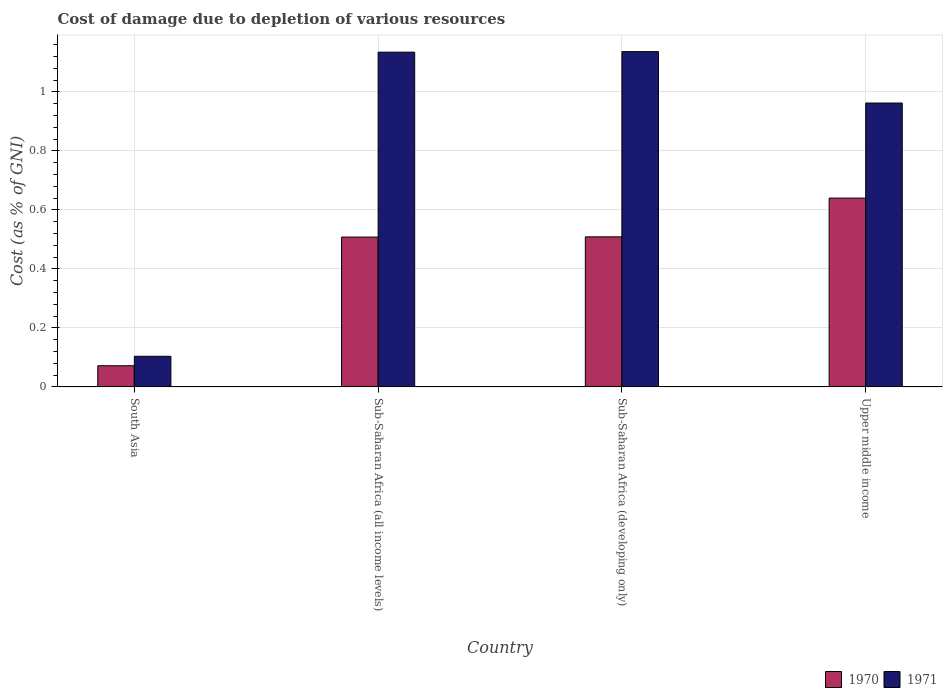How many different coloured bars are there?
Offer a very short reply. 2. How many groups of bars are there?
Make the answer very short. 4. Are the number of bars on each tick of the X-axis equal?
Your answer should be very brief. Yes. What is the label of the 1st group of bars from the left?
Offer a very short reply. South Asia. In how many cases, is the number of bars for a given country not equal to the number of legend labels?
Offer a terse response. 0. What is the cost of damage caused due to the depletion of various resources in 1970 in Sub-Saharan Africa (developing only)?
Your answer should be compact. 0.51. Across all countries, what is the maximum cost of damage caused due to the depletion of various resources in 1970?
Give a very brief answer. 0.64. Across all countries, what is the minimum cost of damage caused due to the depletion of various resources in 1971?
Offer a very short reply. 0.1. In which country was the cost of damage caused due to the depletion of various resources in 1971 maximum?
Provide a succinct answer. Sub-Saharan Africa (developing only). What is the total cost of damage caused due to the depletion of various resources in 1970 in the graph?
Your answer should be very brief. 1.73. What is the difference between the cost of damage caused due to the depletion of various resources in 1971 in South Asia and that in Upper middle income?
Give a very brief answer. -0.86. What is the difference between the cost of damage caused due to the depletion of various resources in 1970 in South Asia and the cost of damage caused due to the depletion of various resources in 1971 in Sub-Saharan Africa (developing only)?
Your answer should be very brief. -1.07. What is the average cost of damage caused due to the depletion of various resources in 1970 per country?
Offer a terse response. 0.43. What is the difference between the cost of damage caused due to the depletion of various resources of/in 1970 and cost of damage caused due to the depletion of various resources of/in 1971 in Sub-Saharan Africa (all income levels)?
Your response must be concise. -0.63. In how many countries, is the cost of damage caused due to the depletion of various resources in 1971 greater than 1.04 %?
Provide a short and direct response. 2. What is the ratio of the cost of damage caused due to the depletion of various resources in 1971 in Sub-Saharan Africa (all income levels) to that in Sub-Saharan Africa (developing only)?
Make the answer very short. 1. What is the difference between the highest and the second highest cost of damage caused due to the depletion of various resources in 1970?
Give a very brief answer. 0.13. What is the difference between the highest and the lowest cost of damage caused due to the depletion of various resources in 1971?
Make the answer very short. 1.03. Are all the bars in the graph horizontal?
Make the answer very short. No. How many countries are there in the graph?
Provide a succinct answer. 4. What is the difference between two consecutive major ticks on the Y-axis?
Provide a short and direct response. 0.2. Are the values on the major ticks of Y-axis written in scientific E-notation?
Make the answer very short. No. Does the graph contain any zero values?
Provide a short and direct response. No. Where does the legend appear in the graph?
Offer a very short reply. Bottom right. What is the title of the graph?
Give a very brief answer. Cost of damage due to depletion of various resources. Does "2009" appear as one of the legend labels in the graph?
Offer a terse response. No. What is the label or title of the Y-axis?
Offer a very short reply. Cost (as % of GNI). What is the Cost (as % of GNI) of 1970 in South Asia?
Offer a terse response. 0.07. What is the Cost (as % of GNI) in 1971 in South Asia?
Make the answer very short. 0.1. What is the Cost (as % of GNI) of 1970 in Sub-Saharan Africa (all income levels)?
Ensure brevity in your answer.  0.51. What is the Cost (as % of GNI) in 1971 in Sub-Saharan Africa (all income levels)?
Your response must be concise. 1.13. What is the Cost (as % of GNI) of 1970 in Sub-Saharan Africa (developing only)?
Give a very brief answer. 0.51. What is the Cost (as % of GNI) in 1971 in Sub-Saharan Africa (developing only)?
Make the answer very short. 1.14. What is the Cost (as % of GNI) of 1970 in Upper middle income?
Your answer should be compact. 0.64. What is the Cost (as % of GNI) of 1971 in Upper middle income?
Keep it short and to the point. 0.96. Across all countries, what is the maximum Cost (as % of GNI) in 1970?
Provide a short and direct response. 0.64. Across all countries, what is the maximum Cost (as % of GNI) of 1971?
Offer a very short reply. 1.14. Across all countries, what is the minimum Cost (as % of GNI) of 1970?
Offer a very short reply. 0.07. Across all countries, what is the minimum Cost (as % of GNI) of 1971?
Offer a terse response. 0.1. What is the total Cost (as % of GNI) in 1970 in the graph?
Your response must be concise. 1.73. What is the total Cost (as % of GNI) in 1971 in the graph?
Give a very brief answer. 3.34. What is the difference between the Cost (as % of GNI) of 1970 in South Asia and that in Sub-Saharan Africa (all income levels)?
Provide a succinct answer. -0.44. What is the difference between the Cost (as % of GNI) in 1971 in South Asia and that in Sub-Saharan Africa (all income levels)?
Ensure brevity in your answer.  -1.03. What is the difference between the Cost (as % of GNI) in 1970 in South Asia and that in Sub-Saharan Africa (developing only)?
Give a very brief answer. -0.44. What is the difference between the Cost (as % of GNI) of 1971 in South Asia and that in Sub-Saharan Africa (developing only)?
Make the answer very short. -1.03. What is the difference between the Cost (as % of GNI) in 1970 in South Asia and that in Upper middle income?
Ensure brevity in your answer.  -0.57. What is the difference between the Cost (as % of GNI) of 1971 in South Asia and that in Upper middle income?
Provide a succinct answer. -0.86. What is the difference between the Cost (as % of GNI) in 1970 in Sub-Saharan Africa (all income levels) and that in Sub-Saharan Africa (developing only)?
Make the answer very short. -0. What is the difference between the Cost (as % of GNI) of 1971 in Sub-Saharan Africa (all income levels) and that in Sub-Saharan Africa (developing only)?
Offer a terse response. -0. What is the difference between the Cost (as % of GNI) of 1970 in Sub-Saharan Africa (all income levels) and that in Upper middle income?
Make the answer very short. -0.13. What is the difference between the Cost (as % of GNI) of 1971 in Sub-Saharan Africa (all income levels) and that in Upper middle income?
Keep it short and to the point. 0.17. What is the difference between the Cost (as % of GNI) of 1970 in Sub-Saharan Africa (developing only) and that in Upper middle income?
Provide a succinct answer. -0.13. What is the difference between the Cost (as % of GNI) in 1971 in Sub-Saharan Africa (developing only) and that in Upper middle income?
Provide a succinct answer. 0.17. What is the difference between the Cost (as % of GNI) of 1970 in South Asia and the Cost (as % of GNI) of 1971 in Sub-Saharan Africa (all income levels)?
Make the answer very short. -1.06. What is the difference between the Cost (as % of GNI) of 1970 in South Asia and the Cost (as % of GNI) of 1971 in Sub-Saharan Africa (developing only)?
Offer a very short reply. -1.07. What is the difference between the Cost (as % of GNI) in 1970 in South Asia and the Cost (as % of GNI) in 1971 in Upper middle income?
Provide a succinct answer. -0.89. What is the difference between the Cost (as % of GNI) of 1970 in Sub-Saharan Africa (all income levels) and the Cost (as % of GNI) of 1971 in Sub-Saharan Africa (developing only)?
Offer a terse response. -0.63. What is the difference between the Cost (as % of GNI) of 1970 in Sub-Saharan Africa (all income levels) and the Cost (as % of GNI) of 1971 in Upper middle income?
Ensure brevity in your answer.  -0.45. What is the difference between the Cost (as % of GNI) in 1970 in Sub-Saharan Africa (developing only) and the Cost (as % of GNI) in 1971 in Upper middle income?
Offer a terse response. -0.45. What is the average Cost (as % of GNI) in 1970 per country?
Your answer should be compact. 0.43. What is the average Cost (as % of GNI) in 1971 per country?
Offer a very short reply. 0.83. What is the difference between the Cost (as % of GNI) of 1970 and Cost (as % of GNI) of 1971 in South Asia?
Make the answer very short. -0.03. What is the difference between the Cost (as % of GNI) in 1970 and Cost (as % of GNI) in 1971 in Sub-Saharan Africa (all income levels)?
Make the answer very short. -0.63. What is the difference between the Cost (as % of GNI) in 1970 and Cost (as % of GNI) in 1971 in Sub-Saharan Africa (developing only)?
Offer a very short reply. -0.63. What is the difference between the Cost (as % of GNI) in 1970 and Cost (as % of GNI) in 1971 in Upper middle income?
Make the answer very short. -0.32. What is the ratio of the Cost (as % of GNI) in 1970 in South Asia to that in Sub-Saharan Africa (all income levels)?
Provide a succinct answer. 0.14. What is the ratio of the Cost (as % of GNI) in 1971 in South Asia to that in Sub-Saharan Africa (all income levels)?
Ensure brevity in your answer.  0.09. What is the ratio of the Cost (as % of GNI) of 1970 in South Asia to that in Sub-Saharan Africa (developing only)?
Keep it short and to the point. 0.14. What is the ratio of the Cost (as % of GNI) of 1971 in South Asia to that in Sub-Saharan Africa (developing only)?
Your answer should be compact. 0.09. What is the ratio of the Cost (as % of GNI) of 1970 in South Asia to that in Upper middle income?
Give a very brief answer. 0.11. What is the ratio of the Cost (as % of GNI) in 1971 in South Asia to that in Upper middle income?
Keep it short and to the point. 0.11. What is the ratio of the Cost (as % of GNI) in 1970 in Sub-Saharan Africa (all income levels) to that in Upper middle income?
Provide a succinct answer. 0.79. What is the ratio of the Cost (as % of GNI) of 1971 in Sub-Saharan Africa (all income levels) to that in Upper middle income?
Offer a terse response. 1.18. What is the ratio of the Cost (as % of GNI) in 1970 in Sub-Saharan Africa (developing only) to that in Upper middle income?
Make the answer very short. 0.79. What is the ratio of the Cost (as % of GNI) in 1971 in Sub-Saharan Africa (developing only) to that in Upper middle income?
Offer a very short reply. 1.18. What is the difference between the highest and the second highest Cost (as % of GNI) in 1970?
Keep it short and to the point. 0.13. What is the difference between the highest and the second highest Cost (as % of GNI) in 1971?
Make the answer very short. 0. What is the difference between the highest and the lowest Cost (as % of GNI) of 1970?
Offer a very short reply. 0.57. What is the difference between the highest and the lowest Cost (as % of GNI) of 1971?
Offer a terse response. 1.03. 